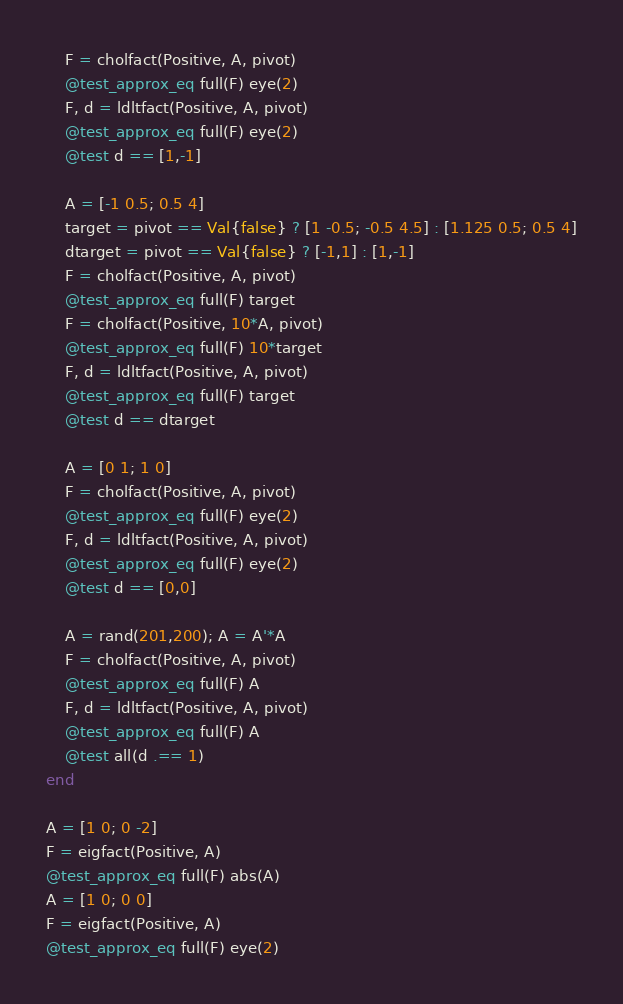Convert code to text. <code><loc_0><loc_0><loc_500><loc_500><_Julia_>    F = cholfact(Positive, A, pivot)
    @test_approx_eq full(F) eye(2)
    F, d = ldltfact(Positive, A, pivot)
    @test_approx_eq full(F) eye(2)
    @test d == [1,-1]

    A = [-1 0.5; 0.5 4]
    target = pivot == Val{false} ? [1 -0.5; -0.5 4.5] : [1.125 0.5; 0.5 4]
    dtarget = pivot == Val{false} ? [-1,1] : [1,-1]
    F = cholfact(Positive, A, pivot)
    @test_approx_eq full(F) target
    F = cholfact(Positive, 10*A, pivot)
    @test_approx_eq full(F) 10*target
    F, d = ldltfact(Positive, A, pivot)
    @test_approx_eq full(F) target
    @test d == dtarget

    A = [0 1; 1 0]
    F = cholfact(Positive, A, pivot)
    @test_approx_eq full(F) eye(2)
    F, d = ldltfact(Positive, A, pivot)
    @test_approx_eq full(F) eye(2)
    @test d == [0,0]

    A = rand(201,200); A = A'*A
    F = cholfact(Positive, A, pivot)
    @test_approx_eq full(F) A
    F, d = ldltfact(Positive, A, pivot)
    @test_approx_eq full(F) A
    @test all(d .== 1)
end

A = [1 0; 0 -2]
F = eigfact(Positive, A)
@test_approx_eq full(F) abs(A)
A = [1 0; 0 0]
F = eigfact(Positive, A)
@test_approx_eq full(F) eye(2)
</code> 